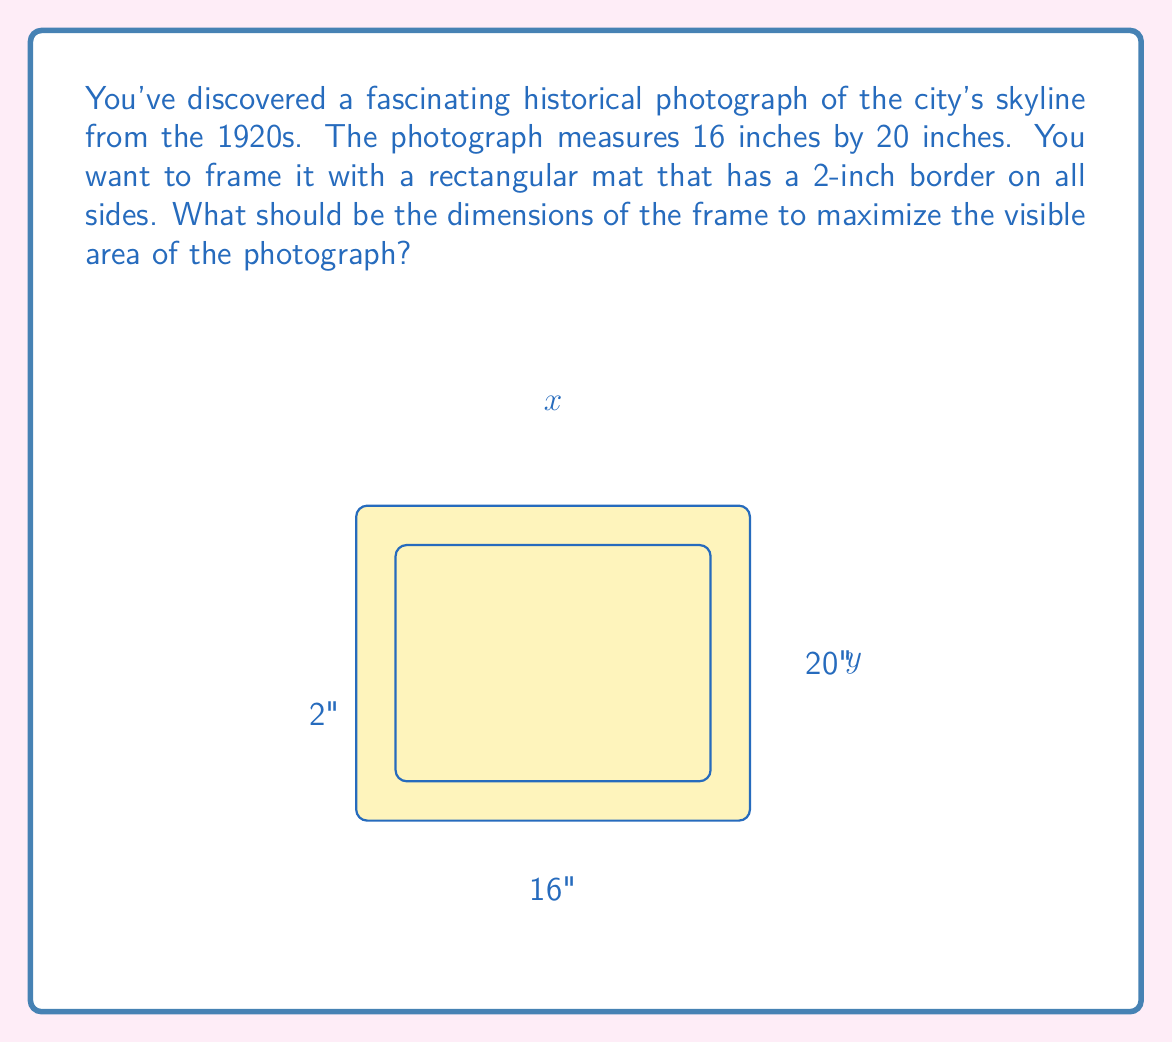Can you solve this math problem? Let's approach this step-by-step:

1) Let $x$ and $y$ be the outer dimensions of the frame.

2) The visible area of the photograph is $(x-4)(y-4)$, as we lose 2 inches on each side due to the mat.

3) The area of the frame is $xy$.

4) The area of the mat is $xy - (x-4)(y-4)$.

5) We want to maximize the visible area relative to the frame area. This can be expressed as a ratio:

   $$A(x,y) = \frac{(x-4)(y-4)}{xy}$$

6) To find the maximum, we need to find where the partial derivatives with respect to $x$ and $y$ are both zero:

   $$\frac{\partial A}{\partial x} = \frac{y(y-4) - xy + 4y}{x^2y} = 0$$
   $$\frac{\partial A}{\partial y} = \frac{x(x-4) - xy + 4x}{xy^2} = 0$$

7) Simplifying these equations:

   $$y^2 - 4y - xy + 4y = 0$$
   $$x^2 - 4x - xy + 4x = 0$$

8) These are equivalent to:

   $$y(y - x) = 0$$
   $$x(x - y) = 0$$

9) The non-trivial solution to both equations is $x = y$.

10) Substituting this back into the original equation:

    $$A(x,x) = \frac{(x-4)^2}{x^2}$$

11) The maximum of this occurs when $x = 8$ (you can verify this by differentiating).

12) Therefore, the optimal frame is a square with side length 24 inches (16 + 2 + 2 + 2 + 2).
Answer: 24 inches by 24 inches 